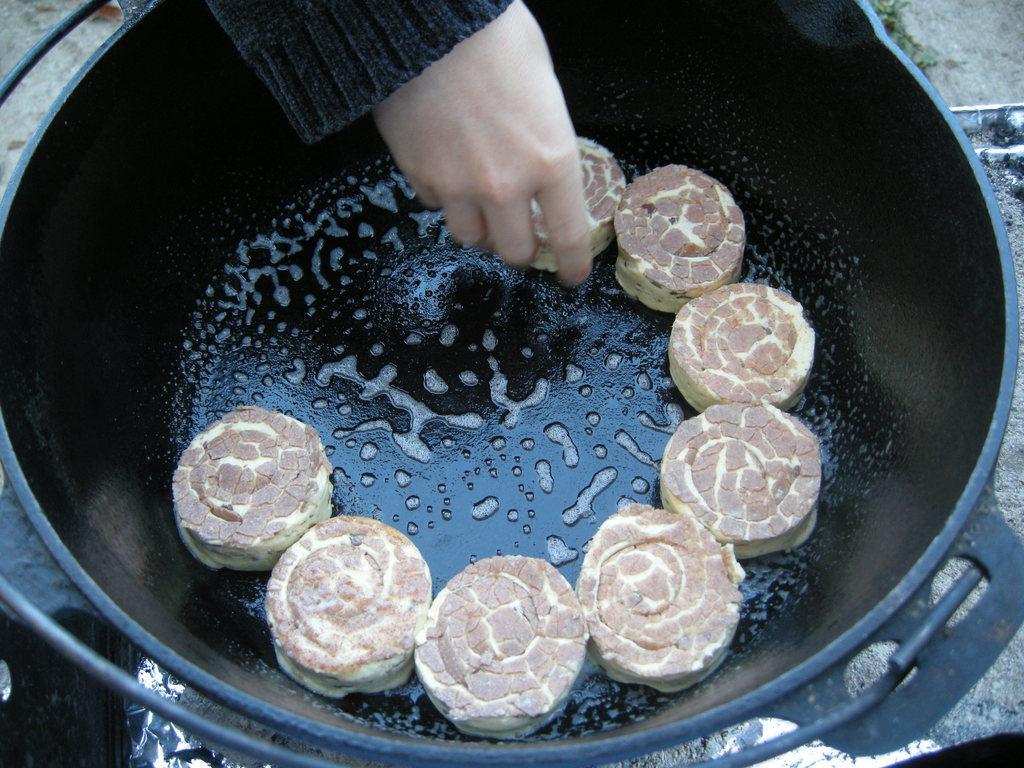Describe this image in one or two sentences. In this picture we can see food in a container. At the top of the image we can see a hand of a person. 